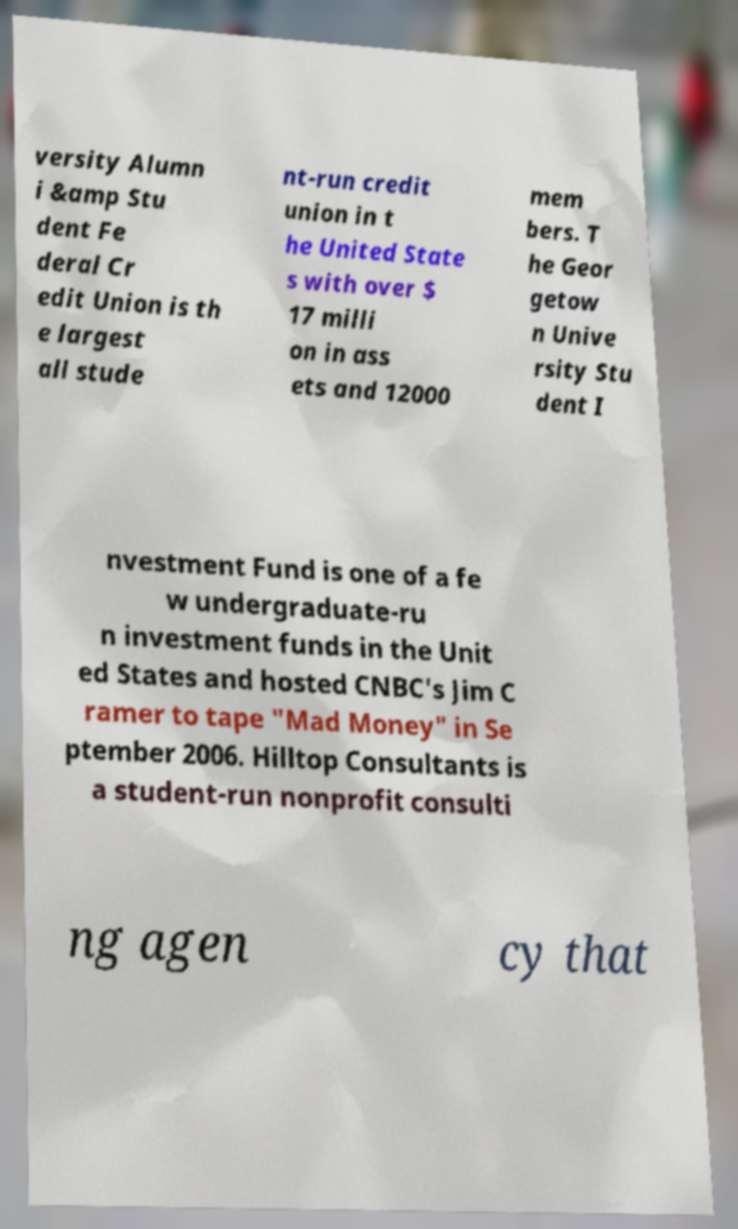Can you accurately transcribe the text from the provided image for me? versity Alumn i &amp Stu dent Fe deral Cr edit Union is th e largest all stude nt-run credit union in t he United State s with over $ 17 milli on in ass ets and 12000 mem bers. T he Geor getow n Unive rsity Stu dent I nvestment Fund is one of a fe w undergraduate-ru n investment funds in the Unit ed States and hosted CNBC's Jim C ramer to tape "Mad Money" in Se ptember 2006. Hilltop Consultants is a student-run nonprofit consulti ng agen cy that 